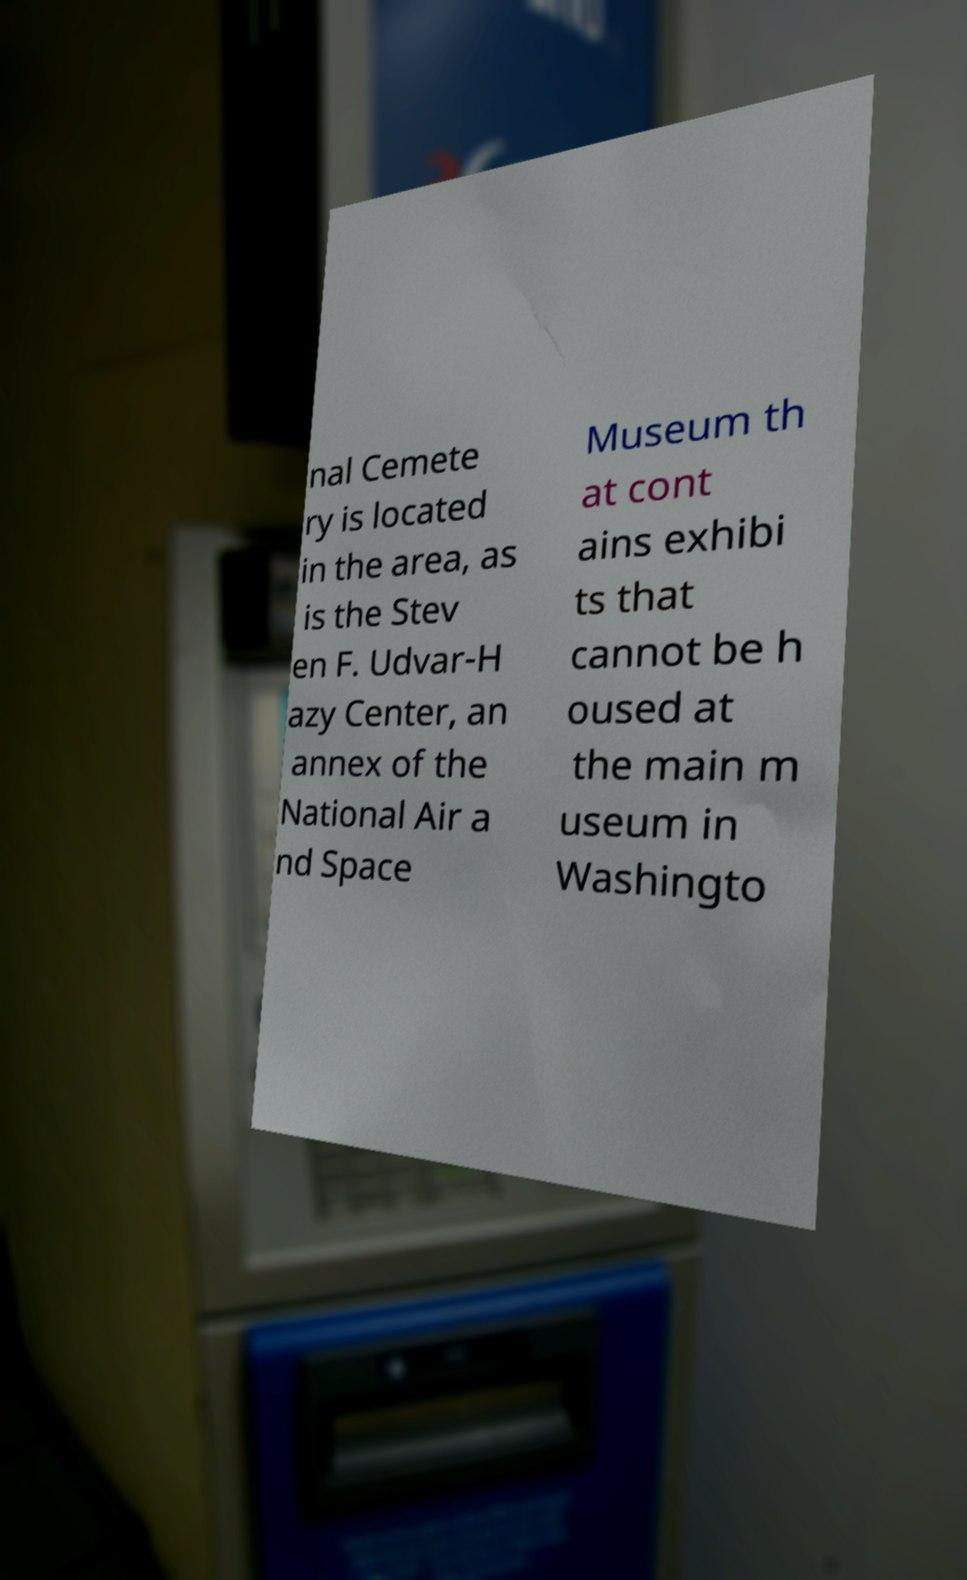For documentation purposes, I need the text within this image transcribed. Could you provide that? nal Cemete ry is located in the area, as is the Stev en F. Udvar-H azy Center, an annex of the National Air a nd Space Museum th at cont ains exhibi ts that cannot be h oused at the main m useum in Washingto 